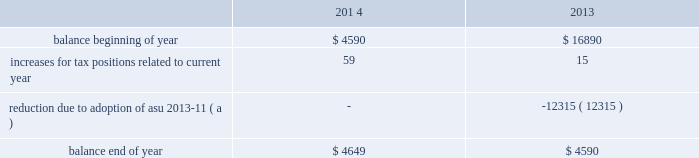Kimco realty corporation and subsidiaries notes to consolidated financial statements , continued uncertain tax positions : the company is subject to income tax in certain jurisdictions outside the u.s. , principally canada and mexico .
The statute of limitations on assessment of tax varies from three to seven years depending on the jurisdiction and tax issue .
Tax returns filed in each jurisdiction are subject to examination by local tax authorities .
The company is currently under audit by the canadian revenue agency , mexican tax authority and the u.s .
Internal revenue service ( 201cirs 201d ) .
In october 2011 , the irs issued a notice of proposed adjustment , which proposes pursuant to section 482 of the code , to disallow a capital loss claimed by krs on the disposition of common shares of valad property ltd. , an australian publicly listed company .
Because the adjustment is being made pursuant to section 482 of the code , the irs believes it can assert a 100 percent 201cpenalty 201d tax pursuant to section 857 ( b ) ( 7 ) of the code and disallow the capital loss deduction .
The notice of proposed adjustment indicates the irs 2019 intention to impose the 100 percent 201cpenalty 201d tax on the company in the amount of $ 40.9 million and disallowing the capital loss claimed by krs .
The company and its outside counsel have considered the irs 2019 assessment and believe that there is sufficient documentation establishing a valid business purpose for the transfer , including recent case history showing support for similar positions .
Accordingly , the company strongly disagrees with the irs 2019 position on the application of section 482 of the code to the disposition of the shares , the imposition of the 100 percent penalty tax and the simultaneous assertion of the penalty tax and disallowance of the capital loss deduction .
The company received a notice of proposed assessment and filed a written protest and requested an irs appeals office conference .
An appeals hearing was attended by management and its attorneys , the irs compliance group and an irs appeals officer in november , 2014 , at which time irs compliance presented arguments in support of their position , as noted herein .
Management and its attorneys presented rebuttal arguments in support of its position .
The matter is currently under consideration by the appeals officer .
The company intends to vigorously defend its position in this matter and believes it will prevail .
Resolutions of these audits are not expected to have a material effect on the company 2019s financial statements .
During 2013 , the company early adopted asu 2013-11 prospectively and reclassified a portion of its reserve for uncertain tax positions .
The reserve for uncertain tax positions included amounts related to the company 2019s canadian operations .
The company has unrecognized tax benefits reported as deferred tax assets and are available to settle adjustments made with respect to the company 2019s uncertain tax positions in canada .
The company reduced its reserve for uncertain tax positions by $ 12.3 million associated with its canadian operations and reduced its deferred tax assets in accordance with asu 2013-11 .
The company does not believe that the total amount of unrecognized tax benefits as of december 31 , 2014 , will significantly increase or decrease within the next 12 months .
As of december 31 , 2014 , the company 2019s canadian uncertain tax positions , which reduce its deferred tax assets , aggregated $ 10.4 million .
The liability for uncertain tax benefits principally consists of estimated foreign , federal and state income tax liabilities in years for which the statute of limitations is open .
Open years range from 2008 through 2014 and vary by jurisdiction and issue .
The aggregate changes in the balance of unrecognized tax benefits for the years ended december 31 , 2014 and 2013 were as follows ( in thousands ) : .
( a ) this amount was reclassified against the related deferred tax asset relating to the company 2019s early adoption of asu 2013-11 as discussed above. .
What is the net change in the balance unrecognized tax benefits in 2013? 
Computations: (15 + -12315)
Answer: -12300.0. Kimco realty corporation and subsidiaries notes to consolidated financial statements , continued uncertain tax positions : the company is subject to income tax in certain jurisdictions outside the u.s. , principally canada and mexico .
The statute of limitations on assessment of tax varies from three to seven years depending on the jurisdiction and tax issue .
Tax returns filed in each jurisdiction are subject to examination by local tax authorities .
The company is currently under audit by the canadian revenue agency , mexican tax authority and the u.s .
Internal revenue service ( 201cirs 201d ) .
In october 2011 , the irs issued a notice of proposed adjustment , which proposes pursuant to section 482 of the code , to disallow a capital loss claimed by krs on the disposition of common shares of valad property ltd. , an australian publicly listed company .
Because the adjustment is being made pursuant to section 482 of the code , the irs believes it can assert a 100 percent 201cpenalty 201d tax pursuant to section 857 ( b ) ( 7 ) of the code and disallow the capital loss deduction .
The notice of proposed adjustment indicates the irs 2019 intention to impose the 100 percent 201cpenalty 201d tax on the company in the amount of $ 40.9 million and disallowing the capital loss claimed by krs .
The company and its outside counsel have considered the irs 2019 assessment and believe that there is sufficient documentation establishing a valid business purpose for the transfer , including recent case history showing support for similar positions .
Accordingly , the company strongly disagrees with the irs 2019 position on the application of section 482 of the code to the disposition of the shares , the imposition of the 100 percent penalty tax and the simultaneous assertion of the penalty tax and disallowance of the capital loss deduction .
The company received a notice of proposed assessment and filed a written protest and requested an irs appeals office conference .
An appeals hearing was attended by management and its attorneys , the irs compliance group and an irs appeals officer in november , 2014 , at which time irs compliance presented arguments in support of their position , as noted herein .
Management and its attorneys presented rebuttal arguments in support of its position .
The matter is currently under consideration by the appeals officer .
The company intends to vigorously defend its position in this matter and believes it will prevail .
Resolutions of these audits are not expected to have a material effect on the company 2019s financial statements .
During 2013 , the company early adopted asu 2013-11 prospectively and reclassified a portion of its reserve for uncertain tax positions .
The reserve for uncertain tax positions included amounts related to the company 2019s canadian operations .
The company has unrecognized tax benefits reported as deferred tax assets and are available to settle adjustments made with respect to the company 2019s uncertain tax positions in canada .
The company reduced its reserve for uncertain tax positions by $ 12.3 million associated with its canadian operations and reduced its deferred tax assets in accordance with asu 2013-11 .
The company does not believe that the total amount of unrecognized tax benefits as of december 31 , 2014 , will significantly increase or decrease within the next 12 months .
As of december 31 , 2014 , the company 2019s canadian uncertain tax positions , which reduce its deferred tax assets , aggregated $ 10.4 million .
The liability for uncertain tax benefits principally consists of estimated foreign , federal and state income tax liabilities in years for which the statute of limitations is open .
Open years range from 2008 through 2014 and vary by jurisdiction and issue .
The aggregate changes in the balance of unrecognized tax benefits for the years ended december 31 , 2014 and 2013 were as follows ( in thousands ) : .
( a ) this amount was reclassified against the related deferred tax asset relating to the company 2019s early adoption of asu 2013-11 as discussed above. .
What is the percentage change in the balance unrecognized tax benefits in 2014? 
Computations: ((4649 - 4590) / 4590)
Answer: 0.01285. Kimco realty corporation and subsidiaries notes to consolidated financial statements , continued uncertain tax positions : the company is subject to income tax in certain jurisdictions outside the u.s. , principally canada and mexico .
The statute of limitations on assessment of tax varies from three to seven years depending on the jurisdiction and tax issue .
Tax returns filed in each jurisdiction are subject to examination by local tax authorities .
The company is currently under audit by the canadian revenue agency , mexican tax authority and the u.s .
Internal revenue service ( 201cirs 201d ) .
In october 2011 , the irs issued a notice of proposed adjustment , which proposes pursuant to section 482 of the code , to disallow a capital loss claimed by krs on the disposition of common shares of valad property ltd. , an australian publicly listed company .
Because the adjustment is being made pursuant to section 482 of the code , the irs believes it can assert a 100 percent 201cpenalty 201d tax pursuant to section 857 ( b ) ( 7 ) of the code and disallow the capital loss deduction .
The notice of proposed adjustment indicates the irs 2019 intention to impose the 100 percent 201cpenalty 201d tax on the company in the amount of $ 40.9 million and disallowing the capital loss claimed by krs .
The company and its outside counsel have considered the irs 2019 assessment and believe that there is sufficient documentation establishing a valid business purpose for the transfer , including recent case history showing support for similar positions .
Accordingly , the company strongly disagrees with the irs 2019 position on the application of section 482 of the code to the disposition of the shares , the imposition of the 100 percent penalty tax and the simultaneous assertion of the penalty tax and disallowance of the capital loss deduction .
The company received a notice of proposed assessment and filed a written protest and requested an irs appeals office conference .
An appeals hearing was attended by management and its attorneys , the irs compliance group and an irs appeals officer in november , 2014 , at which time irs compliance presented arguments in support of their position , as noted herein .
Management and its attorneys presented rebuttal arguments in support of its position .
The matter is currently under consideration by the appeals officer .
The company intends to vigorously defend its position in this matter and believes it will prevail .
Resolutions of these audits are not expected to have a material effect on the company 2019s financial statements .
During 2013 , the company early adopted asu 2013-11 prospectively and reclassified a portion of its reserve for uncertain tax positions .
The reserve for uncertain tax positions included amounts related to the company 2019s canadian operations .
The company has unrecognized tax benefits reported as deferred tax assets and are available to settle adjustments made with respect to the company 2019s uncertain tax positions in canada .
The company reduced its reserve for uncertain tax positions by $ 12.3 million associated with its canadian operations and reduced its deferred tax assets in accordance with asu 2013-11 .
The company does not believe that the total amount of unrecognized tax benefits as of december 31 , 2014 , will significantly increase or decrease within the next 12 months .
As of december 31 , 2014 , the company 2019s canadian uncertain tax positions , which reduce its deferred tax assets , aggregated $ 10.4 million .
The liability for uncertain tax benefits principally consists of estimated foreign , federal and state income tax liabilities in years for which the statute of limitations is open .
Open years range from 2008 through 2014 and vary by jurisdiction and issue .
The aggregate changes in the balance of unrecognized tax benefits for the years ended december 31 , 2014 and 2013 were as follows ( in thousands ) : .
( a ) this amount was reclassified against the related deferred tax asset relating to the company 2019s early adoption of asu 2013-11 as discussed above. .
What was the percentage decrease in the 2013 balance from the beginning of the year to the end of the year? 
Computations: ((16890 - 4590) / 16890)
Answer: 0.72824. Kimco realty corporation and subsidiaries notes to consolidated financial statements , continued uncertain tax positions : the company is subject to income tax in certain jurisdictions outside the u.s. , principally canada and mexico .
The statute of limitations on assessment of tax varies from three to seven years depending on the jurisdiction and tax issue .
Tax returns filed in each jurisdiction are subject to examination by local tax authorities .
The company is currently under audit by the canadian revenue agency , mexican tax authority and the u.s .
Internal revenue service ( 201cirs 201d ) .
In october 2011 , the irs issued a notice of proposed adjustment , which proposes pursuant to section 482 of the code , to disallow a capital loss claimed by krs on the disposition of common shares of valad property ltd. , an australian publicly listed company .
Because the adjustment is being made pursuant to section 482 of the code , the irs believes it can assert a 100 percent 201cpenalty 201d tax pursuant to section 857 ( b ) ( 7 ) of the code and disallow the capital loss deduction .
The notice of proposed adjustment indicates the irs 2019 intention to impose the 100 percent 201cpenalty 201d tax on the company in the amount of $ 40.9 million and disallowing the capital loss claimed by krs .
The company and its outside counsel have considered the irs 2019 assessment and believe that there is sufficient documentation establishing a valid business purpose for the transfer , including recent case history showing support for similar positions .
Accordingly , the company strongly disagrees with the irs 2019 position on the application of section 482 of the code to the disposition of the shares , the imposition of the 100 percent penalty tax and the simultaneous assertion of the penalty tax and disallowance of the capital loss deduction .
The company received a notice of proposed assessment and filed a written protest and requested an irs appeals office conference .
An appeals hearing was attended by management and its attorneys , the irs compliance group and an irs appeals officer in november , 2014 , at which time irs compliance presented arguments in support of their position , as noted herein .
Management and its attorneys presented rebuttal arguments in support of its position .
The matter is currently under consideration by the appeals officer .
The company intends to vigorously defend its position in this matter and believes it will prevail .
Resolutions of these audits are not expected to have a material effect on the company 2019s financial statements .
During 2013 , the company early adopted asu 2013-11 prospectively and reclassified a portion of its reserve for uncertain tax positions .
The reserve for uncertain tax positions included amounts related to the company 2019s canadian operations .
The company has unrecognized tax benefits reported as deferred tax assets and are available to settle adjustments made with respect to the company 2019s uncertain tax positions in canada .
The company reduced its reserve for uncertain tax positions by $ 12.3 million associated with its canadian operations and reduced its deferred tax assets in accordance with asu 2013-11 .
The company does not believe that the total amount of unrecognized tax benefits as of december 31 , 2014 , will significantly increase or decrease within the next 12 months .
As of december 31 , 2014 , the company 2019s canadian uncertain tax positions , which reduce its deferred tax assets , aggregated $ 10.4 million .
The liability for uncertain tax benefits principally consists of estimated foreign , federal and state income tax liabilities in years for which the statute of limitations is open .
Open years range from 2008 through 2014 and vary by jurisdiction and issue .
The aggregate changes in the balance of unrecognized tax benefits for the years ended december 31 , 2014 and 2013 were as follows ( in thousands ) : .
( a ) this amount was reclassified against the related deferred tax asset relating to the company 2019s early adoption of asu 2013-11 as discussed above. .
What is the proportion of dollars at the beginning of both combined years to dollars at end of both combined years? 
Computations: ((4590 + 16890) / (4649 + 4590))
Answer: 2.32493. 